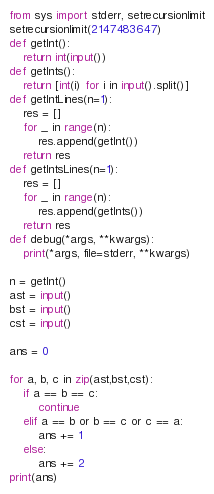Convert code to text. <code><loc_0><loc_0><loc_500><loc_500><_Python_>from sys import stderr, setrecursionlimit
setrecursionlimit(2147483647)
def getInt():
    return int(input())
def getInts():
    return [int(i) for i in input().split()]
def getIntLines(n=1):
    res = []
    for _ in range(n):
        res.append(getInt())
    return res
def getIntsLines(n=1):
    res = []
    for _ in range(n):
        res.append(getInts())
    return res
def debug(*args, **kwargs):
    print(*args, file=stderr, **kwargs)

n = getInt()
ast = input()
bst = input()
cst = input()

ans = 0

for a, b, c in zip(ast,bst,cst):
    if a == b == c:
        continue
    elif a == b or b == c or c == a:
        ans += 1
    else:
        ans += 2
print(ans)</code> 